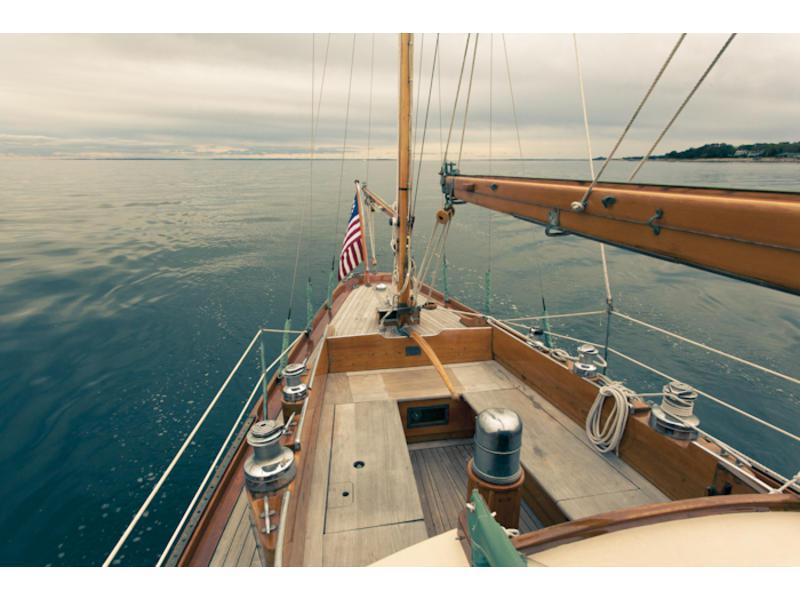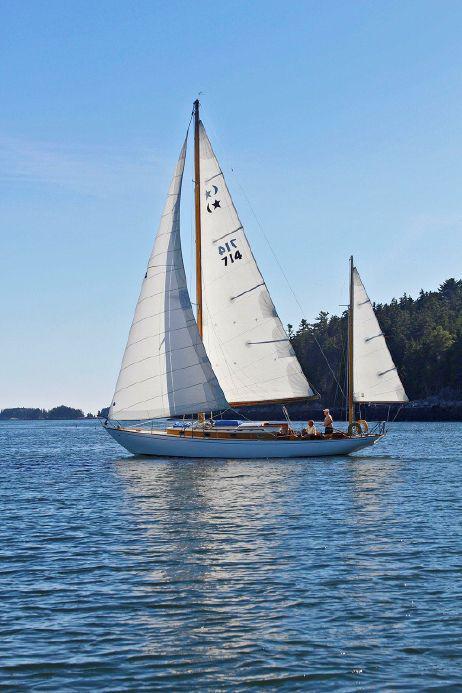The first image is the image on the left, the second image is the image on the right. For the images displayed, is the sentence "There is an American flag visible on a sail boat." factually correct? Answer yes or no. Yes. The first image is the image on the left, the second image is the image on the right. Assess this claim about the two images: "A striped flag is displayed at the front of a boat.". Correct or not? Answer yes or no. Yes. 